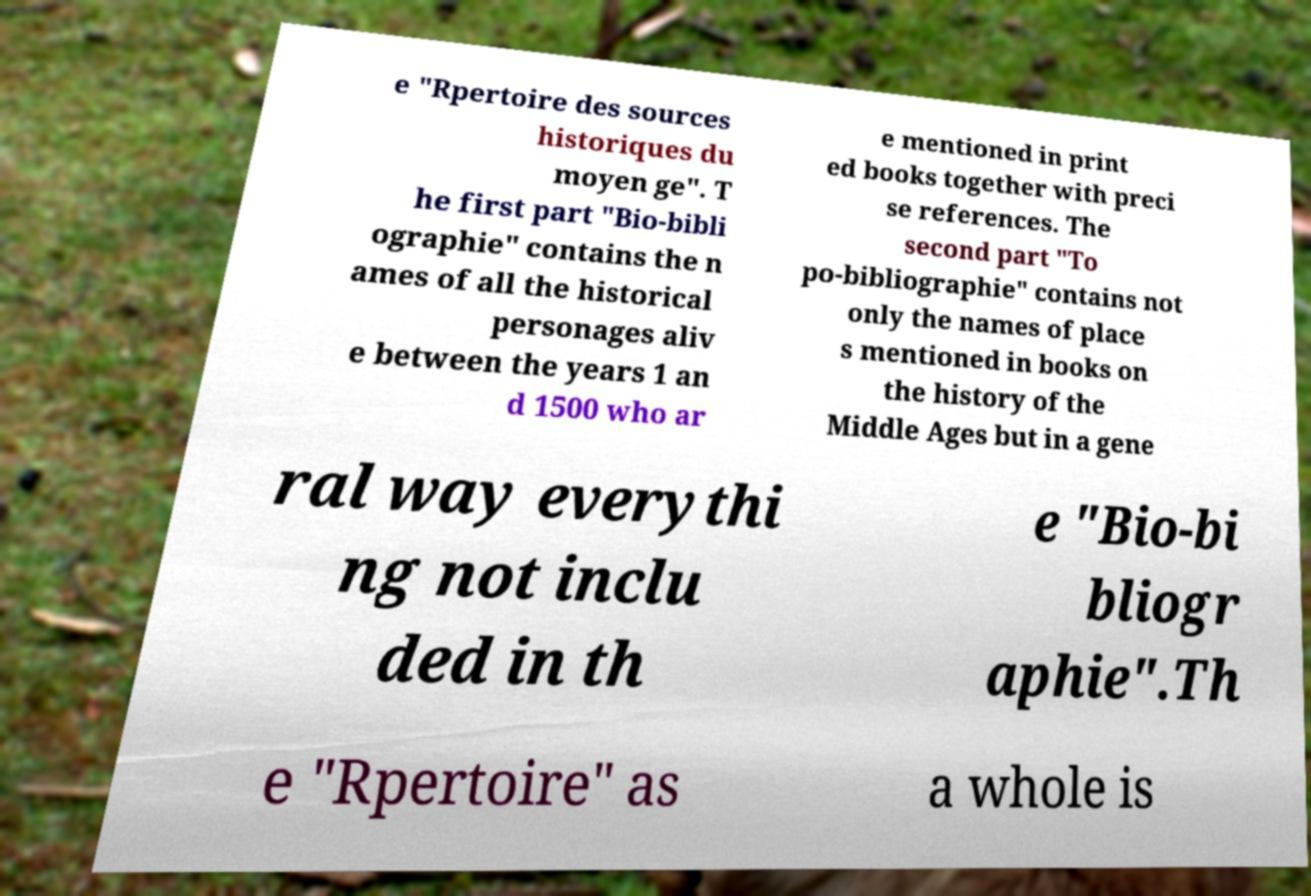There's text embedded in this image that I need extracted. Can you transcribe it verbatim? e "Rpertoire des sources historiques du moyen ge". T he first part "Bio-bibli ographie" contains the n ames of all the historical personages aliv e between the years 1 an d 1500 who ar e mentioned in print ed books together with preci se references. The second part "To po-bibliographie" contains not only the names of place s mentioned in books on the history of the Middle Ages but in a gene ral way everythi ng not inclu ded in th e "Bio-bi bliogr aphie".Th e "Rpertoire" as a whole is 